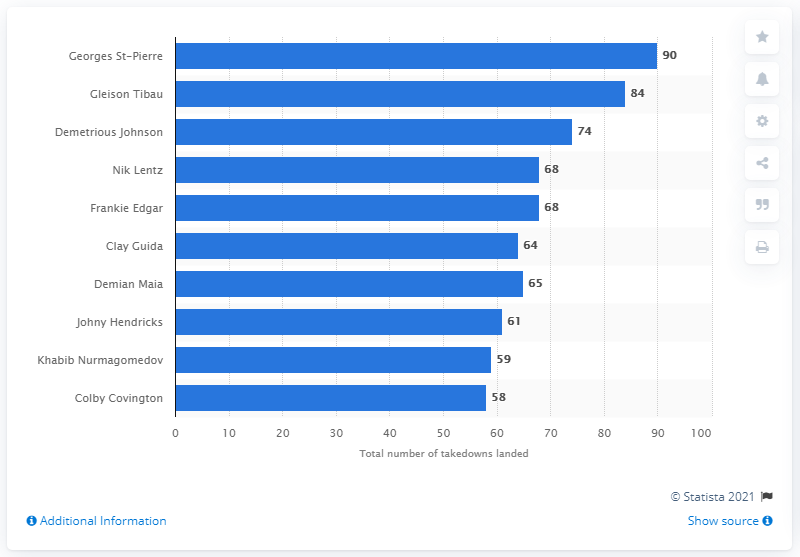Specify some key components in this picture. Demetrious Johnson, a UFC fighter, had a total of 74 takedowns during his fights. Gleison Tibau is currently leading the UFC in the number of successful takedowns, demonstrating his exceptional skill and prowess in the sport. 